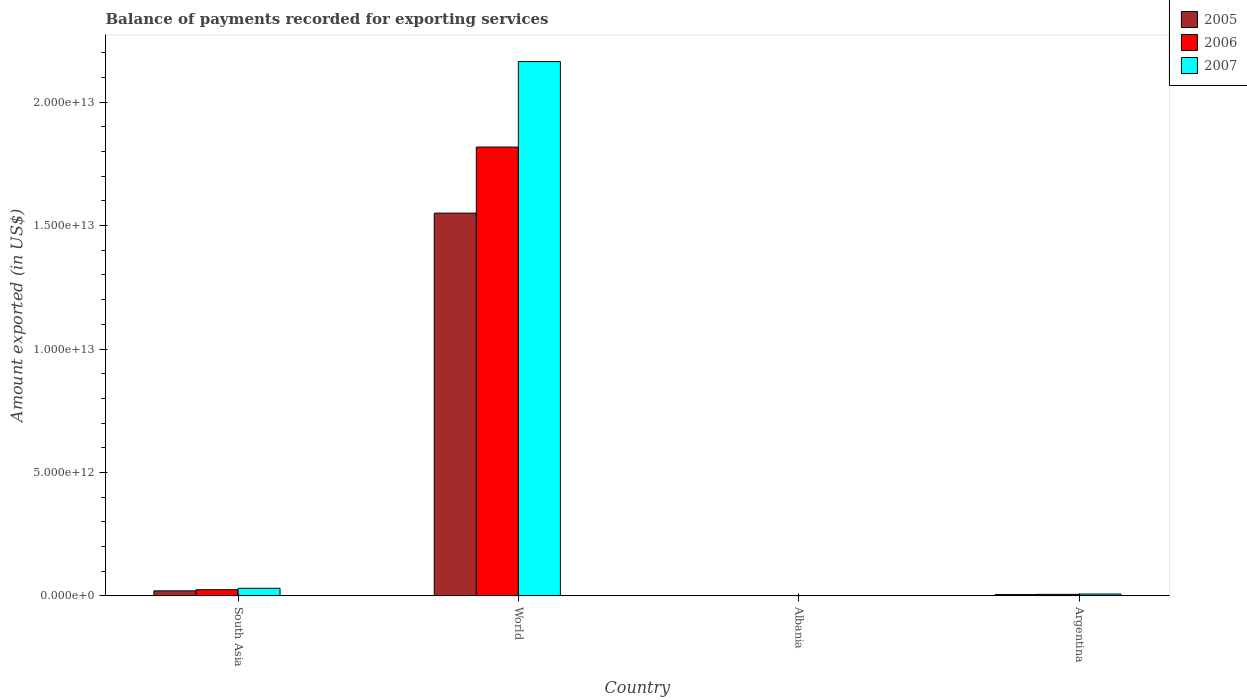Are the number of bars per tick equal to the number of legend labels?
Make the answer very short. Yes. Are the number of bars on each tick of the X-axis equal?
Provide a short and direct response. Yes. How many bars are there on the 3rd tick from the left?
Give a very brief answer. 3. How many bars are there on the 3rd tick from the right?
Make the answer very short. 3. What is the label of the 1st group of bars from the left?
Keep it short and to the point. South Asia. In how many cases, is the number of bars for a given country not equal to the number of legend labels?
Ensure brevity in your answer.  0. What is the amount exported in 2006 in South Asia?
Offer a terse response. 2.48e+11. Across all countries, what is the maximum amount exported in 2007?
Ensure brevity in your answer.  2.16e+13. Across all countries, what is the minimum amount exported in 2005?
Provide a short and direct response. 1.69e+09. In which country was the amount exported in 2007 maximum?
Ensure brevity in your answer.  World. In which country was the amount exported in 2005 minimum?
Keep it short and to the point. Albania. What is the total amount exported in 2005 in the graph?
Offer a terse response. 1.58e+13. What is the difference between the amount exported in 2006 in Albania and that in World?
Provide a short and direct response. -1.82e+13. What is the difference between the amount exported in 2005 in South Asia and the amount exported in 2007 in World?
Make the answer very short. -2.14e+13. What is the average amount exported in 2005 per country?
Provide a succinct answer. 3.94e+12. What is the difference between the amount exported of/in 2006 and amount exported of/in 2007 in World?
Keep it short and to the point. -3.46e+12. What is the ratio of the amount exported in 2007 in Albania to that in World?
Ensure brevity in your answer.  0. What is the difference between the highest and the second highest amount exported in 2005?
Your answer should be compact. -1.51e+11. What is the difference between the highest and the lowest amount exported in 2007?
Ensure brevity in your answer.  2.16e+13. Is the sum of the amount exported in 2007 in South Asia and World greater than the maximum amount exported in 2005 across all countries?
Make the answer very short. Yes. Is it the case that in every country, the sum of the amount exported in 2007 and amount exported in 2006 is greater than the amount exported in 2005?
Make the answer very short. Yes. Are all the bars in the graph horizontal?
Offer a very short reply. No. How many countries are there in the graph?
Ensure brevity in your answer.  4. What is the difference between two consecutive major ticks on the Y-axis?
Ensure brevity in your answer.  5.00e+12. Are the values on the major ticks of Y-axis written in scientific E-notation?
Keep it short and to the point. Yes. Where does the legend appear in the graph?
Ensure brevity in your answer.  Top right. How many legend labels are there?
Your answer should be compact. 3. What is the title of the graph?
Your answer should be very brief. Balance of payments recorded for exporting services. Does "1986" appear as one of the legend labels in the graph?
Ensure brevity in your answer.  No. What is the label or title of the X-axis?
Your answer should be compact. Country. What is the label or title of the Y-axis?
Provide a succinct answer. Amount exported (in US$). What is the Amount exported (in US$) of 2005 in South Asia?
Keep it short and to the point. 2.02e+11. What is the Amount exported (in US$) in 2006 in South Asia?
Provide a short and direct response. 2.48e+11. What is the Amount exported (in US$) in 2007 in South Asia?
Keep it short and to the point. 3.06e+11. What is the Amount exported (in US$) of 2005 in World?
Offer a terse response. 1.55e+13. What is the Amount exported (in US$) of 2006 in World?
Offer a very short reply. 1.82e+13. What is the Amount exported (in US$) of 2007 in World?
Offer a terse response. 2.16e+13. What is the Amount exported (in US$) of 2005 in Albania?
Provide a short and direct response. 1.69e+09. What is the Amount exported (in US$) of 2006 in Albania?
Keep it short and to the point. 2.20e+09. What is the Amount exported (in US$) of 2007 in Albania?
Keep it short and to the point. 2.85e+09. What is the Amount exported (in US$) in 2005 in Argentina?
Your response must be concise. 5.12e+1. What is the Amount exported (in US$) in 2006 in Argentina?
Keep it short and to the point. 6.01e+1. What is the Amount exported (in US$) in 2007 in Argentina?
Make the answer very short. 7.28e+1. Across all countries, what is the maximum Amount exported (in US$) of 2005?
Offer a very short reply. 1.55e+13. Across all countries, what is the maximum Amount exported (in US$) in 2006?
Give a very brief answer. 1.82e+13. Across all countries, what is the maximum Amount exported (in US$) in 2007?
Ensure brevity in your answer.  2.16e+13. Across all countries, what is the minimum Amount exported (in US$) in 2005?
Keep it short and to the point. 1.69e+09. Across all countries, what is the minimum Amount exported (in US$) in 2006?
Ensure brevity in your answer.  2.20e+09. Across all countries, what is the minimum Amount exported (in US$) in 2007?
Offer a very short reply. 2.85e+09. What is the total Amount exported (in US$) of 2005 in the graph?
Your response must be concise. 1.58e+13. What is the total Amount exported (in US$) of 2006 in the graph?
Provide a succinct answer. 1.85e+13. What is the total Amount exported (in US$) of 2007 in the graph?
Offer a very short reply. 2.20e+13. What is the difference between the Amount exported (in US$) of 2005 in South Asia and that in World?
Make the answer very short. -1.53e+13. What is the difference between the Amount exported (in US$) of 2006 in South Asia and that in World?
Your answer should be very brief. -1.79e+13. What is the difference between the Amount exported (in US$) of 2007 in South Asia and that in World?
Your answer should be very brief. -2.13e+13. What is the difference between the Amount exported (in US$) in 2005 in South Asia and that in Albania?
Your answer should be very brief. 2.00e+11. What is the difference between the Amount exported (in US$) in 2006 in South Asia and that in Albania?
Your answer should be very brief. 2.46e+11. What is the difference between the Amount exported (in US$) of 2007 in South Asia and that in Albania?
Give a very brief answer. 3.03e+11. What is the difference between the Amount exported (in US$) of 2005 in South Asia and that in Argentina?
Offer a terse response. 1.51e+11. What is the difference between the Amount exported (in US$) of 2006 in South Asia and that in Argentina?
Keep it short and to the point. 1.88e+11. What is the difference between the Amount exported (in US$) of 2007 in South Asia and that in Argentina?
Give a very brief answer. 2.33e+11. What is the difference between the Amount exported (in US$) in 2005 in World and that in Albania?
Your answer should be compact. 1.55e+13. What is the difference between the Amount exported (in US$) in 2006 in World and that in Albania?
Give a very brief answer. 1.82e+13. What is the difference between the Amount exported (in US$) of 2007 in World and that in Albania?
Give a very brief answer. 2.16e+13. What is the difference between the Amount exported (in US$) of 2005 in World and that in Argentina?
Offer a very short reply. 1.55e+13. What is the difference between the Amount exported (in US$) of 2006 in World and that in Argentina?
Provide a succinct answer. 1.81e+13. What is the difference between the Amount exported (in US$) of 2007 in World and that in Argentina?
Ensure brevity in your answer.  2.16e+13. What is the difference between the Amount exported (in US$) of 2005 in Albania and that in Argentina?
Offer a terse response. -4.95e+1. What is the difference between the Amount exported (in US$) in 2006 in Albania and that in Argentina?
Keep it short and to the point. -5.79e+1. What is the difference between the Amount exported (in US$) of 2007 in Albania and that in Argentina?
Provide a succinct answer. -6.99e+1. What is the difference between the Amount exported (in US$) of 2005 in South Asia and the Amount exported (in US$) of 2006 in World?
Your response must be concise. -1.80e+13. What is the difference between the Amount exported (in US$) of 2005 in South Asia and the Amount exported (in US$) of 2007 in World?
Provide a short and direct response. -2.14e+13. What is the difference between the Amount exported (in US$) in 2006 in South Asia and the Amount exported (in US$) in 2007 in World?
Your answer should be very brief. -2.14e+13. What is the difference between the Amount exported (in US$) in 2005 in South Asia and the Amount exported (in US$) in 2006 in Albania?
Offer a terse response. 2.00e+11. What is the difference between the Amount exported (in US$) of 2005 in South Asia and the Amount exported (in US$) of 2007 in Albania?
Ensure brevity in your answer.  1.99e+11. What is the difference between the Amount exported (in US$) in 2006 in South Asia and the Amount exported (in US$) in 2007 in Albania?
Your response must be concise. 2.45e+11. What is the difference between the Amount exported (in US$) in 2005 in South Asia and the Amount exported (in US$) in 2006 in Argentina?
Keep it short and to the point. 1.42e+11. What is the difference between the Amount exported (in US$) of 2005 in South Asia and the Amount exported (in US$) of 2007 in Argentina?
Provide a short and direct response. 1.29e+11. What is the difference between the Amount exported (in US$) in 2006 in South Asia and the Amount exported (in US$) in 2007 in Argentina?
Your response must be concise. 1.76e+11. What is the difference between the Amount exported (in US$) of 2005 in World and the Amount exported (in US$) of 2006 in Albania?
Offer a terse response. 1.55e+13. What is the difference between the Amount exported (in US$) of 2005 in World and the Amount exported (in US$) of 2007 in Albania?
Offer a terse response. 1.55e+13. What is the difference between the Amount exported (in US$) of 2006 in World and the Amount exported (in US$) of 2007 in Albania?
Ensure brevity in your answer.  1.82e+13. What is the difference between the Amount exported (in US$) of 2005 in World and the Amount exported (in US$) of 2006 in Argentina?
Keep it short and to the point. 1.54e+13. What is the difference between the Amount exported (in US$) in 2005 in World and the Amount exported (in US$) in 2007 in Argentina?
Your answer should be very brief. 1.54e+13. What is the difference between the Amount exported (in US$) of 2006 in World and the Amount exported (in US$) of 2007 in Argentina?
Offer a terse response. 1.81e+13. What is the difference between the Amount exported (in US$) in 2005 in Albania and the Amount exported (in US$) in 2006 in Argentina?
Keep it short and to the point. -5.84e+1. What is the difference between the Amount exported (in US$) in 2005 in Albania and the Amount exported (in US$) in 2007 in Argentina?
Your answer should be very brief. -7.11e+1. What is the difference between the Amount exported (in US$) in 2006 in Albania and the Amount exported (in US$) in 2007 in Argentina?
Ensure brevity in your answer.  -7.06e+1. What is the average Amount exported (in US$) in 2005 per country?
Keep it short and to the point. 3.94e+12. What is the average Amount exported (in US$) in 2006 per country?
Your answer should be very brief. 4.62e+12. What is the average Amount exported (in US$) in 2007 per country?
Your answer should be very brief. 5.51e+12. What is the difference between the Amount exported (in US$) of 2005 and Amount exported (in US$) of 2006 in South Asia?
Make the answer very short. -4.61e+1. What is the difference between the Amount exported (in US$) in 2005 and Amount exported (in US$) in 2007 in South Asia?
Ensure brevity in your answer.  -1.04e+11. What is the difference between the Amount exported (in US$) of 2006 and Amount exported (in US$) of 2007 in South Asia?
Offer a very short reply. -5.78e+1. What is the difference between the Amount exported (in US$) of 2005 and Amount exported (in US$) of 2006 in World?
Keep it short and to the point. -2.68e+12. What is the difference between the Amount exported (in US$) of 2005 and Amount exported (in US$) of 2007 in World?
Provide a succinct answer. -6.14e+12. What is the difference between the Amount exported (in US$) in 2006 and Amount exported (in US$) in 2007 in World?
Keep it short and to the point. -3.46e+12. What is the difference between the Amount exported (in US$) in 2005 and Amount exported (in US$) in 2006 in Albania?
Offer a very short reply. -5.14e+08. What is the difference between the Amount exported (in US$) of 2005 and Amount exported (in US$) of 2007 in Albania?
Offer a terse response. -1.16e+09. What is the difference between the Amount exported (in US$) of 2006 and Amount exported (in US$) of 2007 in Albania?
Offer a terse response. -6.45e+08. What is the difference between the Amount exported (in US$) in 2005 and Amount exported (in US$) in 2006 in Argentina?
Your answer should be compact. -8.91e+09. What is the difference between the Amount exported (in US$) in 2005 and Amount exported (in US$) in 2007 in Argentina?
Your response must be concise. -2.16e+1. What is the difference between the Amount exported (in US$) of 2006 and Amount exported (in US$) of 2007 in Argentina?
Your answer should be compact. -1.27e+1. What is the ratio of the Amount exported (in US$) of 2005 in South Asia to that in World?
Keep it short and to the point. 0.01. What is the ratio of the Amount exported (in US$) in 2006 in South Asia to that in World?
Provide a succinct answer. 0.01. What is the ratio of the Amount exported (in US$) of 2007 in South Asia to that in World?
Ensure brevity in your answer.  0.01. What is the ratio of the Amount exported (in US$) in 2005 in South Asia to that in Albania?
Give a very brief answer. 119.81. What is the ratio of the Amount exported (in US$) of 2006 in South Asia to that in Albania?
Provide a succinct answer. 112.78. What is the ratio of the Amount exported (in US$) of 2007 in South Asia to that in Albania?
Keep it short and to the point. 107.53. What is the ratio of the Amount exported (in US$) in 2005 in South Asia to that in Argentina?
Your answer should be compact. 3.95. What is the ratio of the Amount exported (in US$) in 2006 in South Asia to that in Argentina?
Provide a short and direct response. 4.13. What is the ratio of the Amount exported (in US$) in 2007 in South Asia to that in Argentina?
Keep it short and to the point. 4.21. What is the ratio of the Amount exported (in US$) of 2005 in World to that in Albania?
Make the answer very short. 9189.13. What is the ratio of the Amount exported (in US$) of 2006 in World to that in Albania?
Make the answer very short. 8258.95. What is the ratio of the Amount exported (in US$) in 2007 in World to that in Albania?
Make the answer very short. 7603.71. What is the ratio of the Amount exported (in US$) in 2005 in World to that in Argentina?
Give a very brief answer. 302.83. What is the ratio of the Amount exported (in US$) of 2006 in World to that in Argentina?
Your response must be concise. 302.47. What is the ratio of the Amount exported (in US$) of 2007 in World to that in Argentina?
Your answer should be very brief. 297.37. What is the ratio of the Amount exported (in US$) in 2005 in Albania to that in Argentina?
Give a very brief answer. 0.03. What is the ratio of the Amount exported (in US$) of 2006 in Albania to that in Argentina?
Give a very brief answer. 0.04. What is the ratio of the Amount exported (in US$) of 2007 in Albania to that in Argentina?
Keep it short and to the point. 0.04. What is the difference between the highest and the second highest Amount exported (in US$) of 2005?
Your answer should be compact. 1.53e+13. What is the difference between the highest and the second highest Amount exported (in US$) of 2006?
Keep it short and to the point. 1.79e+13. What is the difference between the highest and the second highest Amount exported (in US$) in 2007?
Ensure brevity in your answer.  2.13e+13. What is the difference between the highest and the lowest Amount exported (in US$) in 2005?
Your response must be concise. 1.55e+13. What is the difference between the highest and the lowest Amount exported (in US$) of 2006?
Your response must be concise. 1.82e+13. What is the difference between the highest and the lowest Amount exported (in US$) in 2007?
Provide a succinct answer. 2.16e+13. 